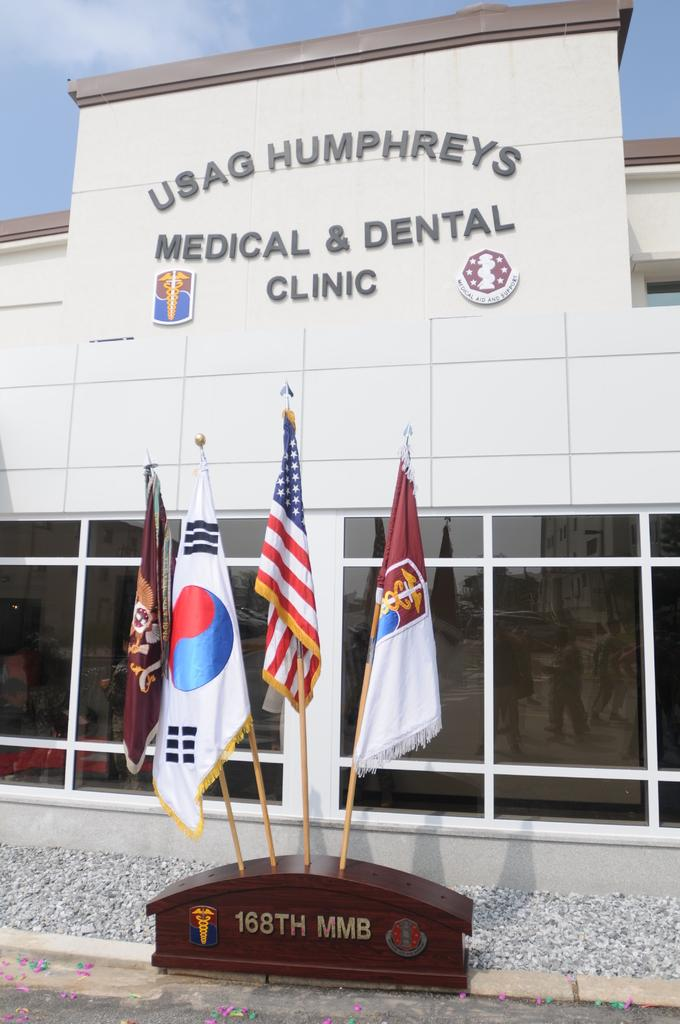What type of structure is present in the image? There is a building in the image. What feature can be seen on the building? There are windows visible on the building. What additional information can be found in the image? There is text visible in the image. What objects are related to the building in the image? There are flags and stones in the image. What can be seen in the background of the image? The sky is visible in the image. Reasoning: Let's think step by step by step in order to produce the conversation. We start by identifying the main subject in the image, which is the building. Then, we expand the conversation to include other details about the building, such as the presence of windows, text, flags, and stones. We also mention the sky visible in the background. Each question is designed to elicit a specific detail about the image that is known from the provided facts. Absurd Question/Answer: How many zebras can be seen writing in a notebook in the image? There are no zebras or notebooks present in the image. 